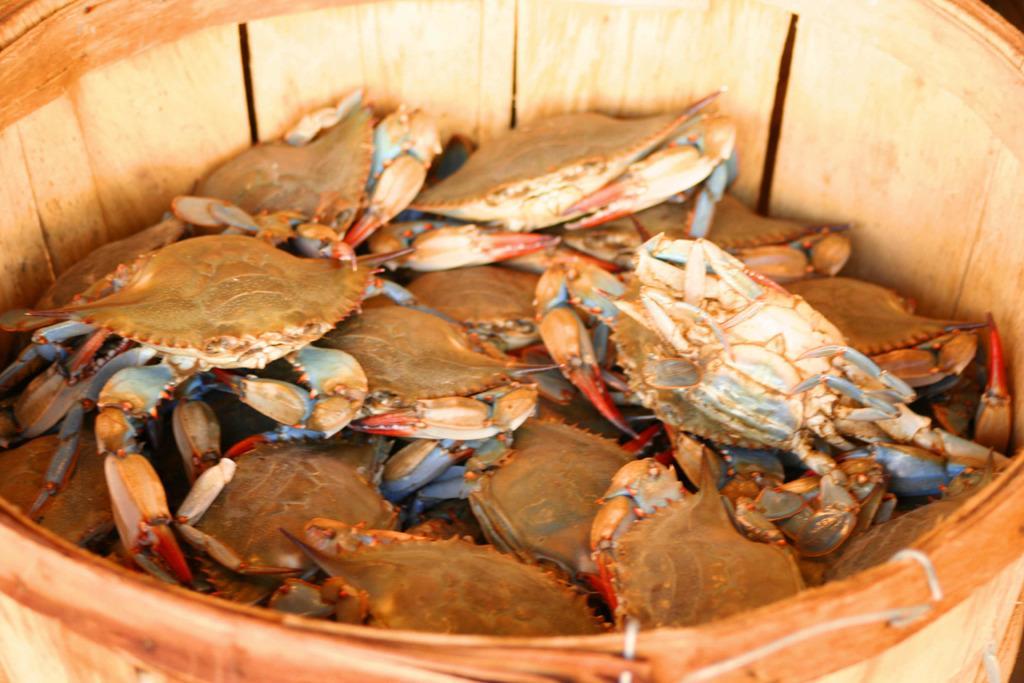How would you summarize this image in a sentence or two? In this image I see the bucket in which there are number of crabs. 